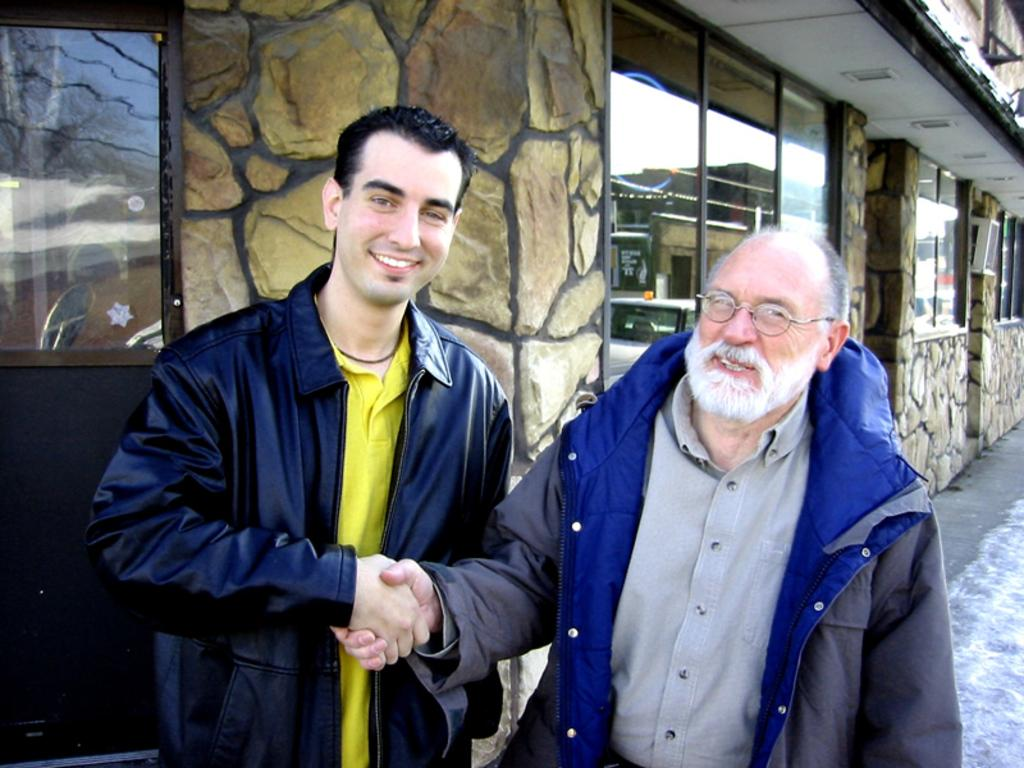How many people are in the image? There are two persons in the image. Where are the two persons located in the image? The two persons are standing in the center of the image. What are the two persons doing in the image? The two persons are shaking hands. What expressions do the two persons have in the image? The two persons have smiles on their faces. What can be seen in the background of the image? There is a building in the background of the image. Can you see any kittens playing near the lake in the image? There is no lake or kittens present in the image. 